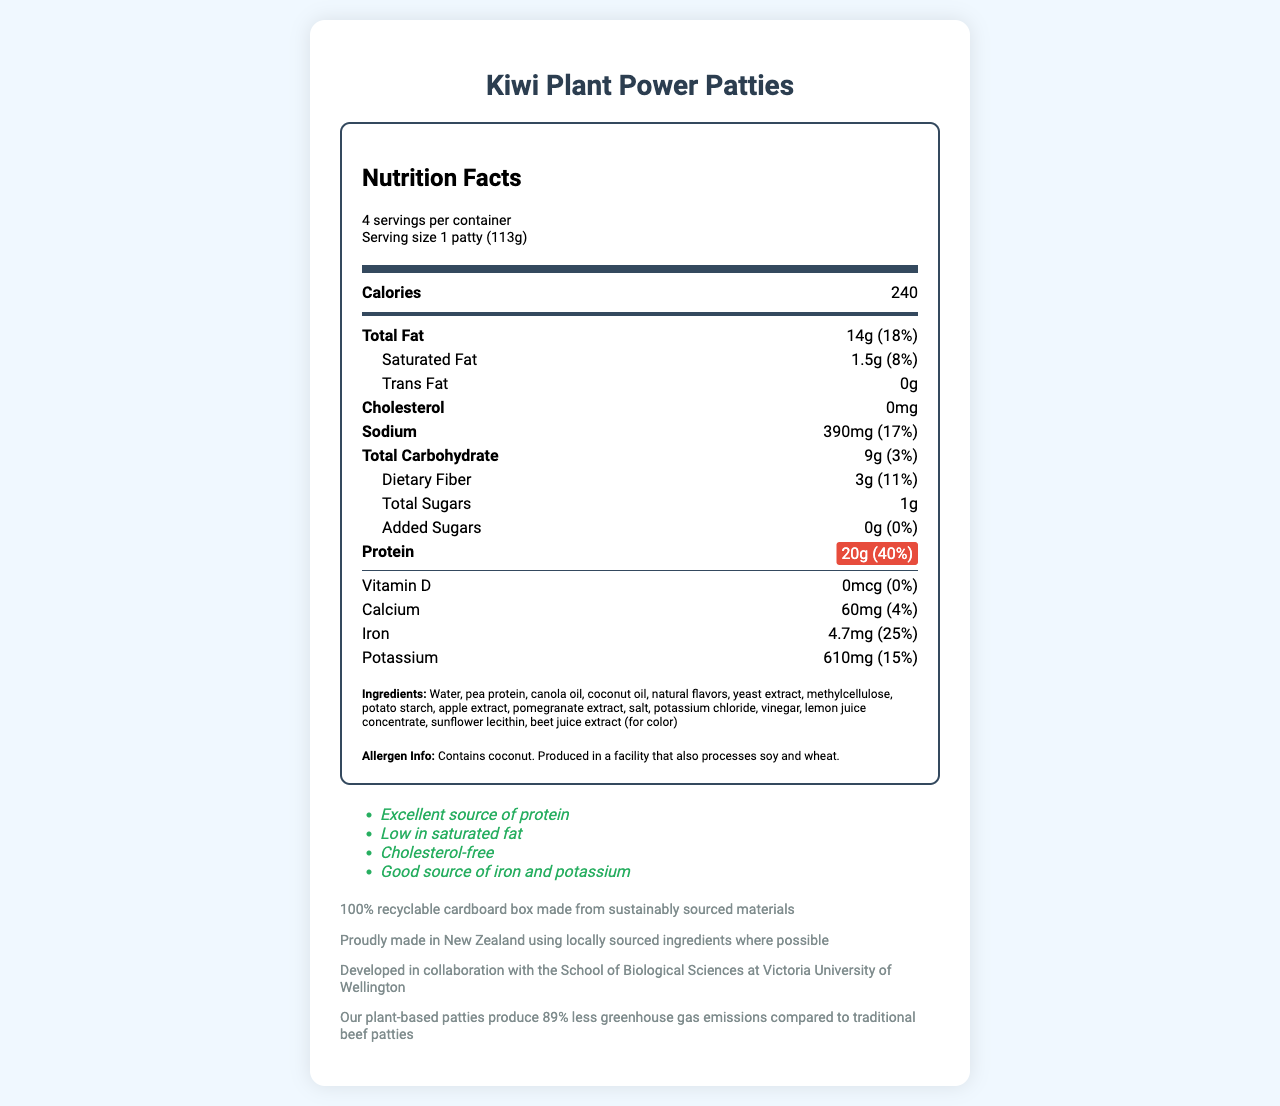what is the serving size for Kiwi Plant Power Patties? The document clearly states the serving size as "1 patty (113g)" under the serving info section.
Answer: 1 patty (113g) how many servings are there per container? The document lists "4 servings per container" in the serving info section.
Answer: 4 how much protein does one patty contain? The protein content is highlighted in the nutrient row as "20g" per serving.
Answer: 20g what is the total fat content per serving? The total fat content per serving is mentioned as "14g" with a daily value of "18%" in the nutrient row.
Answer: 14g (18%) what are the main ingredients in Kiwi Plant Power Patties? The ingredients are listed clearly towards the end of the document.
Answer: Water, pea protein, canola oil, coconut oil, natural flavors, yeast extract, methylcellulose, potato starch, apple extract, pomegranate extract, salt, potassium chloride, vinegar, lemon juice concentrate, sunflower lecithin, beet juice extract (for color) which of the following is NOT a health claim made about the product? A. High in Vitamin D B. Excellent source of protein C. Low in saturated fat D. Cholesterol-free The document lists health claims such as "Excellent source of protein", "Low in saturated fat", and "Cholesterol-free", but does not claim it to be high in Vitamin D.
Answer: A what is the daily value percentage of iron per serving? A. 4% B. 15% C. 25% D. 40% The daily value percentage of iron per serving is listed as "25%" in the nutrient row.
Answer: C is there any cholesterol in Kiwi Plant Power Patties? The nutrient row shows that the cholesterol content is "0mg".
Answer: No summarize the main idea of this document. The entire document details the nutrition information, health claims, ingredients, allergen info, and additional statements about the product’s environmental impact and collaboration with the university.
Answer: The document provides the nutrition facts and other relevant information for Kiwi Plant Power Patties, which is a plant-based meat alternative. Key highlights include 20g of protein per serving, low saturated fat, no cholesterol, and various health claims such as being an excellent source of protein and a good source of iron and potassium. It also mentions the product's eco-friendly packaging and its development in collaboration with the Victoria University of Wellington. who is the primary target audience for this product? The document does not explicitly state who the primary target audience is.
Answer: Not enough information what is the total carbohydrate content in one serving? The total carbohydrate content per serving is "9g" with a daily value percentage of "3%" in the nutrient row.
Answer: 9g (3%) 